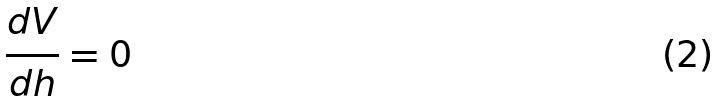<formula> <loc_0><loc_0><loc_500><loc_500>\frac { d V } { d h } = 0</formula> 